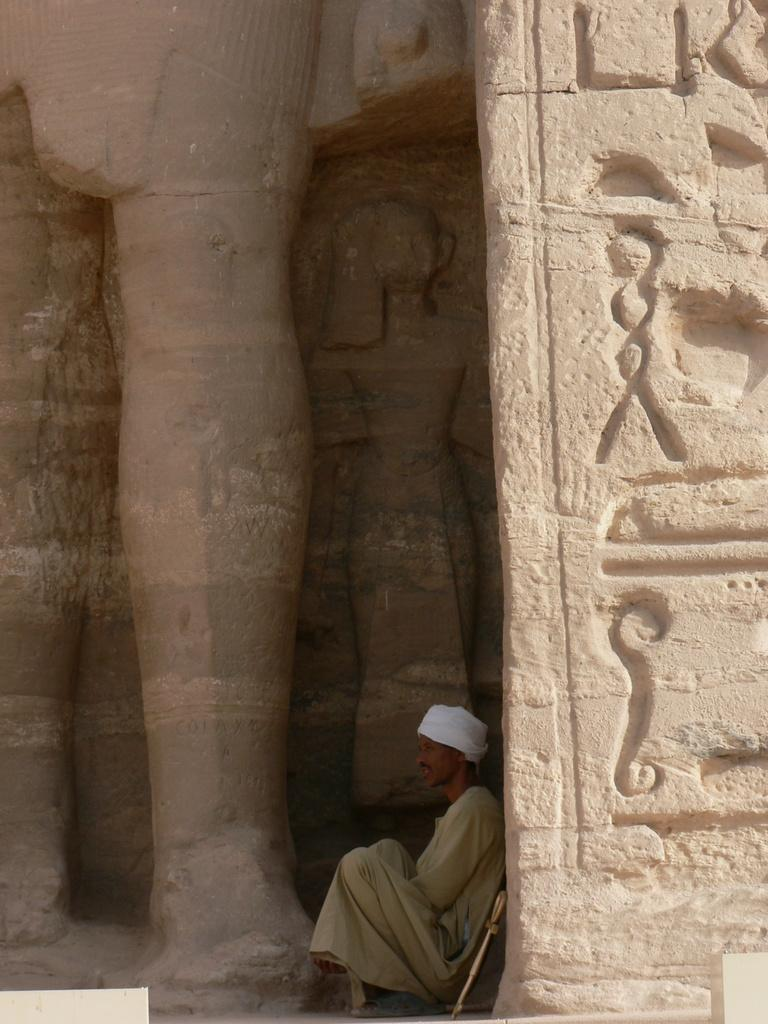What type of structure is depicted in the image? There is a sculptured wall in the image. What is the man in the image doing? The man is sitting near the wall and leaning against it. How can we identify the man in the image? The man is wearing a white cap. What type of cherry is the man eating in the image? There is no cherry present in the image, and the man is not eating anything. What type of judgment is the man making in the image? There is no indication of the man making any judgment in the image. 